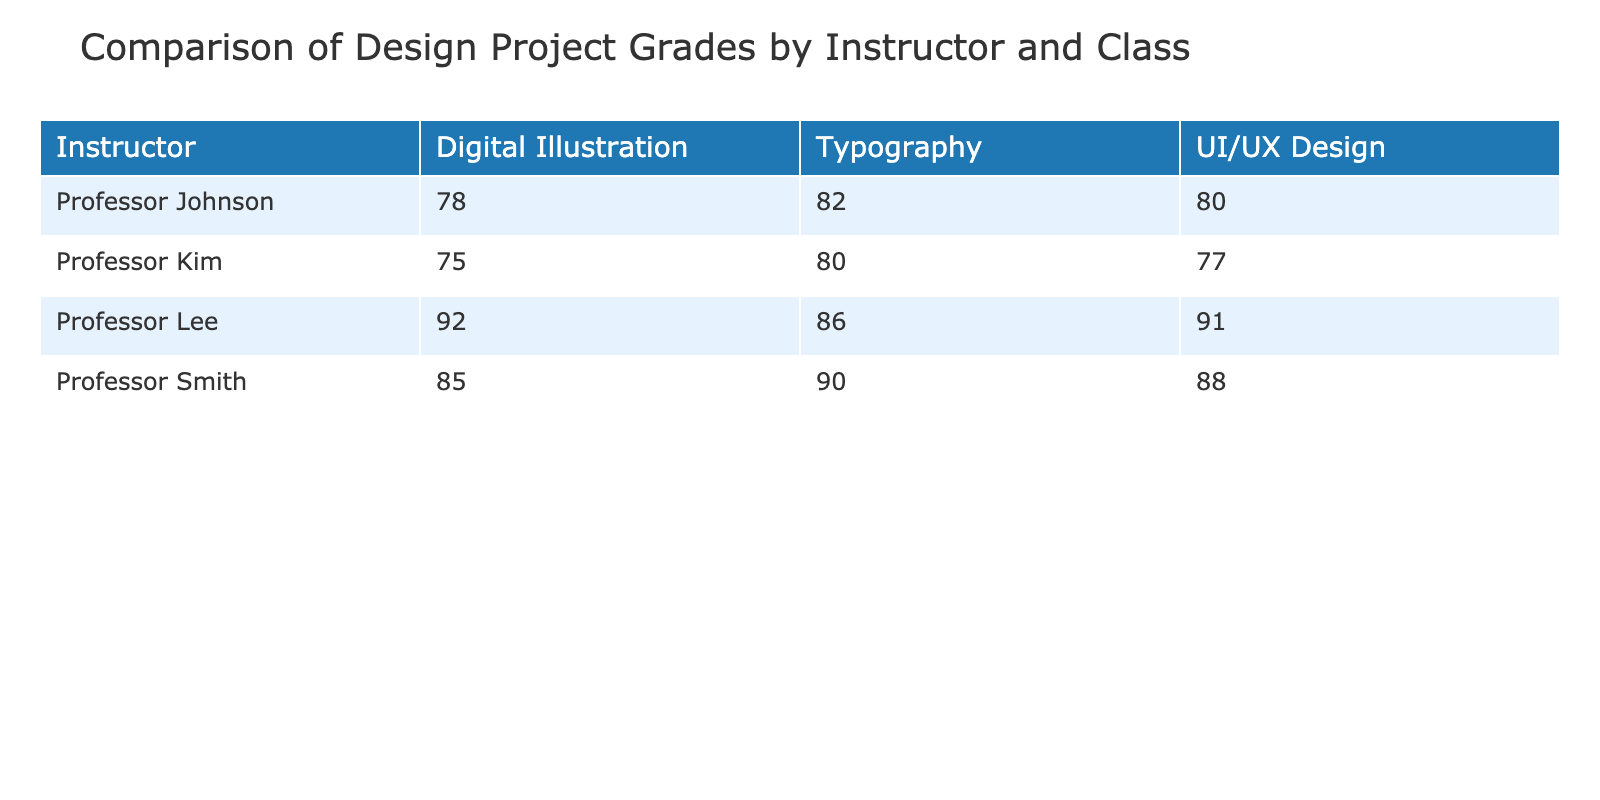What is the highest grade awarded by Professor Lee? To find the highest grade by Professor Lee, we look at the grades under his row: Digital Illustration (92), Typography (86), and UI/UX Design (91). The highest among these is 92 for Digital Illustration.
Answer: 92 What is the average grade for Typography across all instructors? We take the grades for Typography: 90 (Smith), 82 (Johnson), 86 (Lee), and 80 (Kim). The sum of these grades is 90 + 82 + 86 + 80 = 338. There are 4 entries for Typography, so the average is 338 / 4 = 84.5.
Answer: 84.5 Did Professor Johnson receive a higher grade for UI/UX Design than for Typography? We compare the grades: Professor Johnson received 80 for UI/UX Design and 82 for Typography. Since 80 is less than 82, the answer is no.
Answer: No What is the total of the grades awarded by Professor Kim? To find the total grades given by Professor Kim, we sum up the grades: Digital Illustration (75), Typography (80), and UI/UX Design (77). The total is 75 + 80 + 77 = 232.
Answer: 232 Which instructor has the lowest average grade across all classes? The average grades by instructor are calculated as follows: Professor Smith: (85 + 90 + 88) / 3 = 87.67, Professor Johnson: (78 + 82 + 80) / 3 = 80, Professor Lee: (92 + 86 + 91) / 3 = 89.67, Professor Kim: (75 + 80 + 77) / 3 = 77.33. The lowest average is for Professor Kim at 77.33.
Answer: Professor Kim What is the difference between the highest and lowest grades for Digital Illustration? We identify the grades for Digital Illustration: 85 (Smith), 78 (Johnson), 92 (Lee), and 75 (Kim). The highest grade is 92 (Lee) and the lowest is 75 (Kim). The difference is 92 - 75 = 17.
Answer: 17 Is there any class where Professor Smith's grade is the lowest among all instructors? We see the grades for each class: Digital Illustration (85), Typography (90), UI/UX Design (88). In comparison, for Digital Illustration, Professor Smith (85) is lower than Professor Lee (92); for Typography, he is not lower; and for UI/UX Design he is also not lower. Thus, he has the lowest in Digital Illustration only.
Answer: Yes What is the average grade for Digital Illustration? The grades for Digital Illustration are 85 (Smith), 78 (Johnson), 92 (Lee), and 75 (Kim). So, we sum these grades: 85 + 78 + 92 + 75 = 330, then divide by 4 for the average: 330 / 4 = 82.5.
Answer: 82.5 Who has the highest grade in UI/UX Design? We compare the UI/UX Design grades: Smith (88), Johnson (80), Lee (91), Kim (77). The highest grade is 91 from Professor Lee.
Answer: Professor Lee 